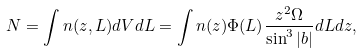<formula> <loc_0><loc_0><loc_500><loc_500>N = \int n ( z , L ) d V d L = \int n ( z ) \Phi ( L ) \frac { z ^ { 2 } \Omega } { \sin ^ { 3 } | b | } d L d z ,</formula> 